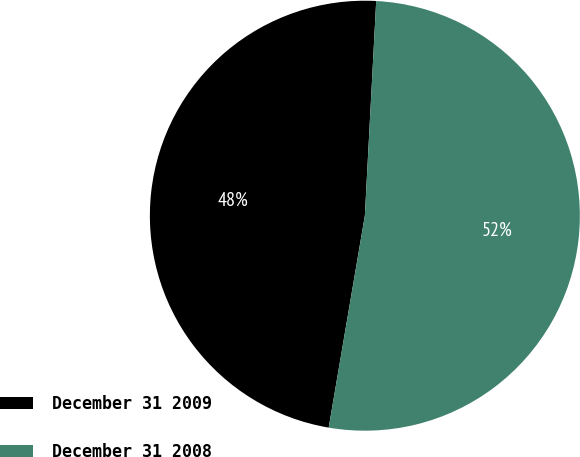<chart> <loc_0><loc_0><loc_500><loc_500><pie_chart><fcel>December 31 2009<fcel>December 31 2008<nl><fcel>48.15%<fcel>51.85%<nl></chart> 